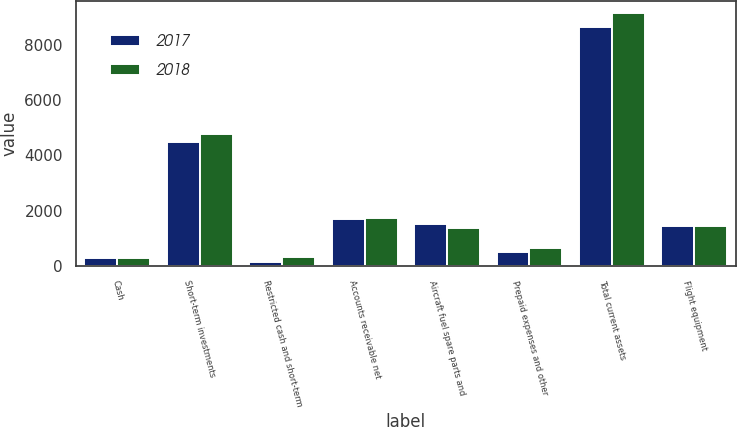Convert chart. <chart><loc_0><loc_0><loc_500><loc_500><stacked_bar_chart><ecel><fcel>Cash<fcel>Short-term investments<fcel>Restricted cash and short-term<fcel>Accounts receivable net<fcel>Aircraft fuel spare parts and<fcel>Prepaid expenses and other<fcel>Total current assets<fcel>Flight equipment<nl><fcel>2017<fcel>275<fcel>4485<fcel>154<fcel>1706<fcel>1522<fcel>495<fcel>8637<fcel>1440.5<nl><fcel>2018<fcel>295<fcel>4771<fcel>318<fcel>1752<fcel>1359<fcel>651<fcel>9146<fcel>1440.5<nl></chart> 